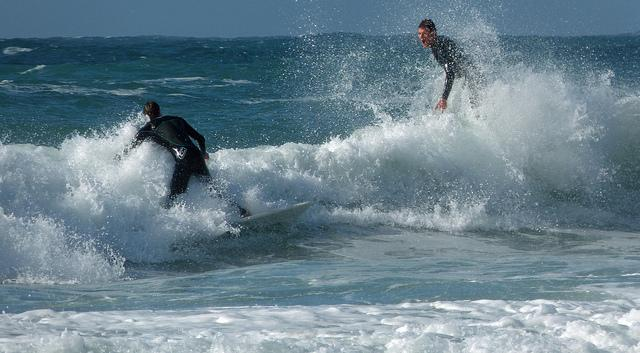Why is the surfer wearing a wetsuit? Please explain your reasoning. insulation. The ocean can have very cold water, and a wetsuit protects one's body from the elements. 